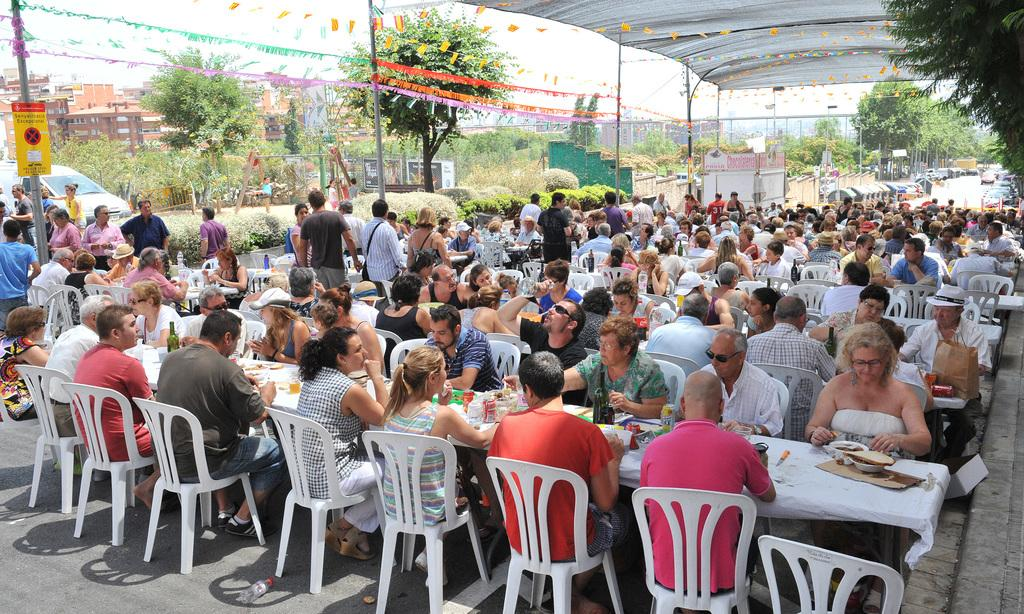What are the people in the image doing? People are sitting around the table in the image. What are the people sitting on? The people are sitting in chairs. What is on the table with the people? There is a bowl, a knife, and food on the table. What can be seen in the background of the image? There are trees, a building, and a car in the background. What type of linen is being used by the women in the image? There are no women present in the image, and no linen is visible. What drug is being discussed by the people at the table? There is no mention or indication of any drug in the image. 